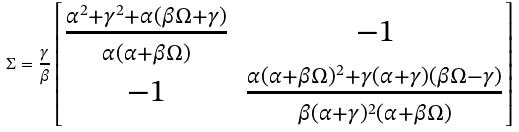Convert formula to latex. <formula><loc_0><loc_0><loc_500><loc_500>\Sigma = \frac { \gamma } { \beta } \begin{bmatrix} \frac { \alpha ^ { 2 } + \gamma ^ { 2 } + \alpha ( \beta \Omega + \gamma ) } { \alpha ( \alpha + \beta \Omega ) } & - 1 \\ - 1 & \frac { \alpha ( \alpha + \beta \Omega ) ^ { 2 } + \gamma ( \alpha + \gamma ) ( \beta \Omega - \gamma ) } { \beta ( \alpha + \gamma ) ^ { 2 } ( \alpha + \beta \Omega ) } \end{bmatrix}</formula> 